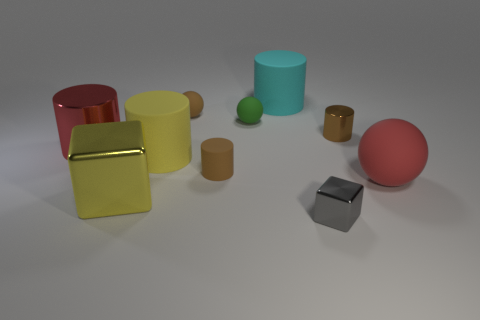Subtract all small green spheres. How many spheres are left? 2 Subtract all red spheres. How many spheres are left? 2 Subtract all cubes. How many objects are left? 8 Subtract all cyan spheres. How many brown cylinders are left? 2 Subtract 2 balls. How many balls are left? 1 Subtract all tiny purple rubber objects. Subtract all gray shiny blocks. How many objects are left? 9 Add 7 green matte things. How many green matte things are left? 8 Add 4 small shiny cylinders. How many small shiny cylinders exist? 5 Subtract 0 purple spheres. How many objects are left? 10 Subtract all cyan cylinders. Subtract all purple balls. How many cylinders are left? 4 